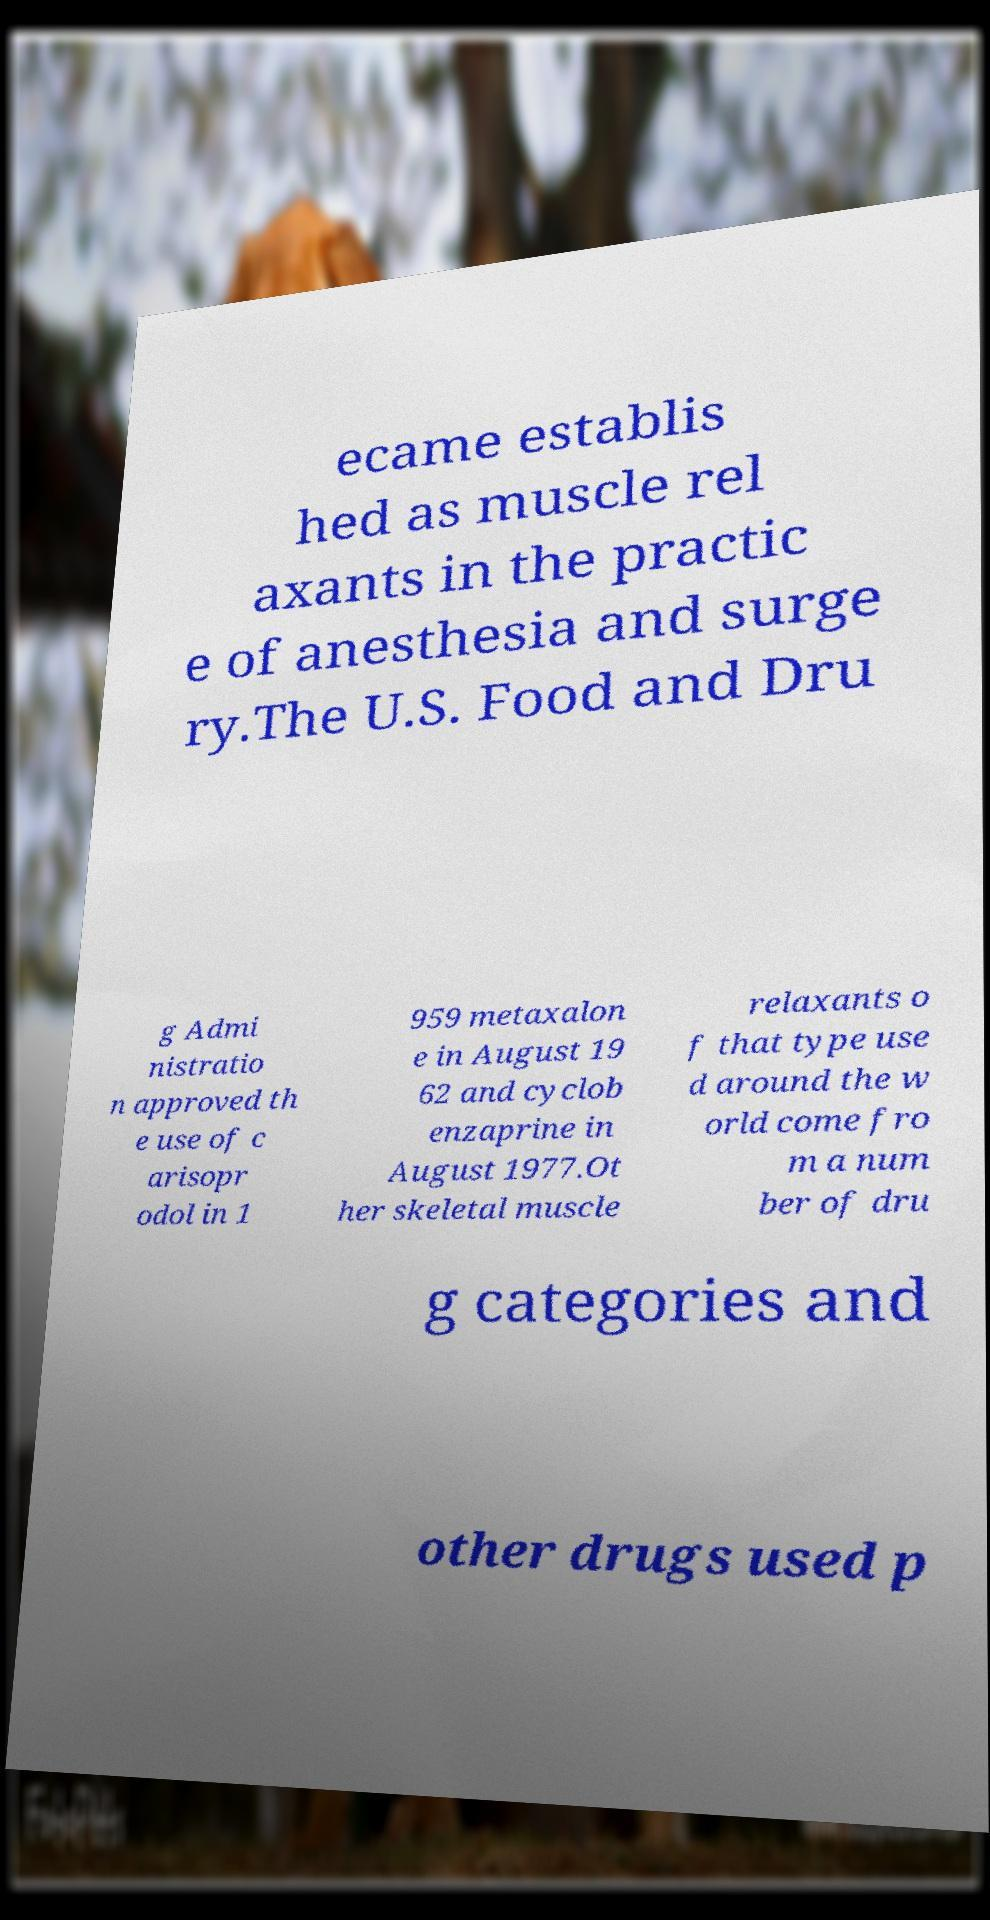Can you accurately transcribe the text from the provided image for me? ecame establis hed as muscle rel axants in the practic e of anesthesia and surge ry.The U.S. Food and Dru g Admi nistratio n approved th e use of c arisopr odol in 1 959 metaxalon e in August 19 62 and cyclob enzaprine in August 1977.Ot her skeletal muscle relaxants o f that type use d around the w orld come fro m a num ber of dru g categories and other drugs used p 